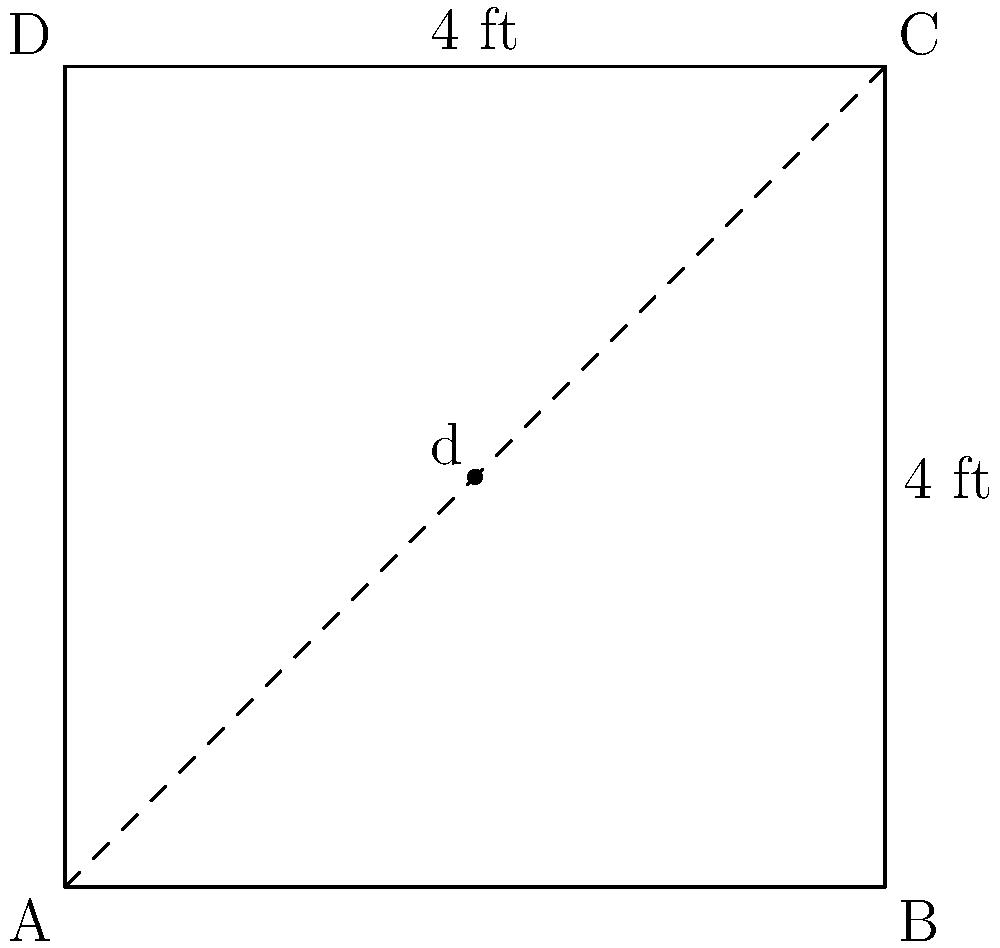You have a square yoga mat with sides measuring 4 feet. What is the length of the diagonal across the mat? To find the diagonal length of a square yoga mat, we can use the Pythagorean theorem. Here's how:

1. In a square, the diagonal forms a right triangle with two sides of the square.

2. We know each side of the square (yoga mat) is 4 feet long.

3. Let's call the diagonal length $d$.

4. Using the Pythagorean theorem: $a^2 + b^2 = c^2$
   Where $a$ and $b$ are the sides of the square, and $c$ is the diagonal.

5. Plugging in our values: $4^2 + 4^2 = d^2$

6. Simplify: $16 + 16 = d^2$

7. Add: $32 = d^2$

8. Take the square root of both sides: $\sqrt{32} = d$

9. Simplify: $d = 4\sqrt{2}$ feet

10. If you need a decimal approximation: $4\sqrt{2} \approx 5.66$ feet

So, the diagonal of your square yoga mat is $4\sqrt{2}$ feet, or approximately 5.66 feet.
Answer: $4\sqrt{2}$ feet 